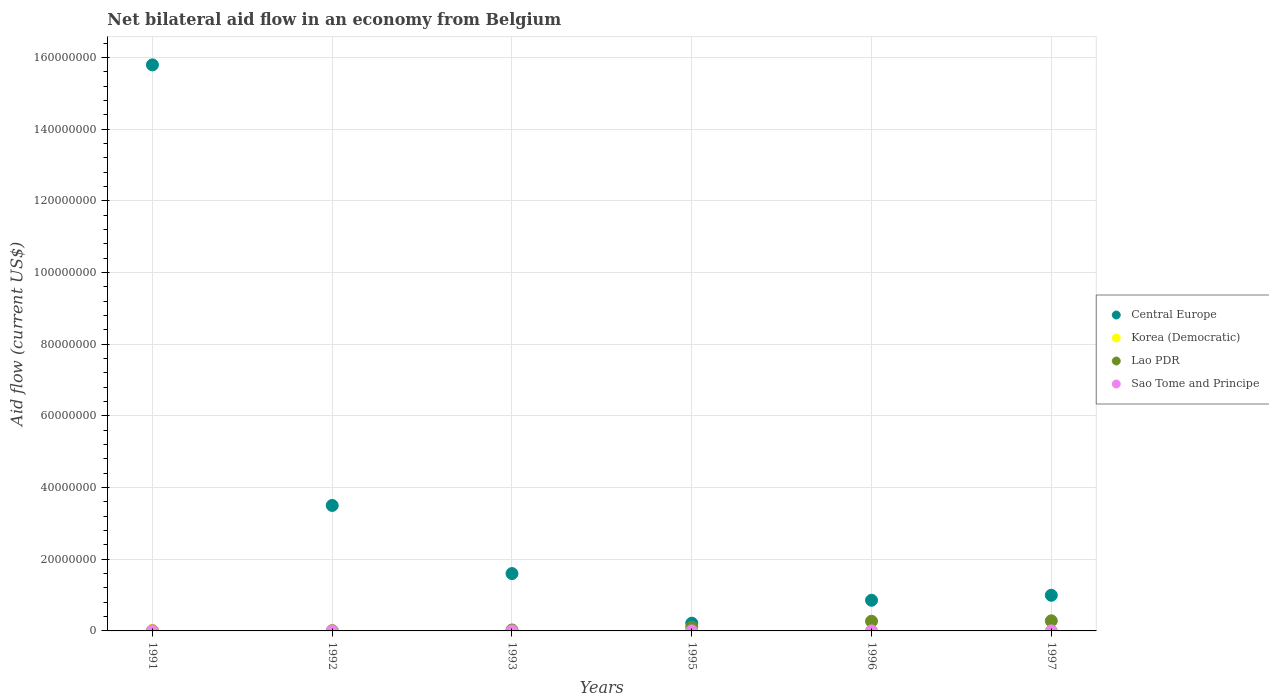How many different coloured dotlines are there?
Make the answer very short. 4. What is the net bilateral aid flow in Lao PDR in 1995?
Offer a terse response. 1.03e+06. Across all years, what is the minimum net bilateral aid flow in Korea (Democratic)?
Your response must be concise. 10000. What is the total net bilateral aid flow in Central Europe in the graph?
Provide a succinct answer. 2.30e+08. What is the difference between the net bilateral aid flow in Korea (Democratic) in 1997 and the net bilateral aid flow in Lao PDR in 1996?
Give a very brief answer. -2.69e+06. In the year 1997, what is the difference between the net bilateral aid flow in Lao PDR and net bilateral aid flow in Sao Tome and Principe?
Your answer should be very brief. 2.81e+06. In how many years, is the net bilateral aid flow in Central Europe greater than 44000000 US$?
Your response must be concise. 1. Is the difference between the net bilateral aid flow in Lao PDR in 1991 and 1992 greater than the difference between the net bilateral aid flow in Sao Tome and Principe in 1991 and 1992?
Give a very brief answer. No. What is the difference between the highest and the second highest net bilateral aid flow in Lao PDR?
Provide a short and direct response. 1.20e+05. What is the difference between the highest and the lowest net bilateral aid flow in Lao PDR?
Provide a succinct answer. 2.80e+06. Is it the case that in every year, the sum of the net bilateral aid flow in Korea (Democratic) and net bilateral aid flow in Sao Tome and Principe  is greater than the sum of net bilateral aid flow in Central Europe and net bilateral aid flow in Lao PDR?
Offer a very short reply. No. Is it the case that in every year, the sum of the net bilateral aid flow in Central Europe and net bilateral aid flow in Korea (Democratic)  is greater than the net bilateral aid flow in Lao PDR?
Your answer should be very brief. Yes. How many dotlines are there?
Provide a short and direct response. 4. Are the values on the major ticks of Y-axis written in scientific E-notation?
Offer a terse response. No. Where does the legend appear in the graph?
Your answer should be very brief. Center right. How are the legend labels stacked?
Make the answer very short. Vertical. What is the title of the graph?
Offer a very short reply. Net bilateral aid flow in an economy from Belgium. What is the label or title of the X-axis?
Ensure brevity in your answer.  Years. What is the label or title of the Y-axis?
Ensure brevity in your answer.  Aid flow (current US$). What is the Aid flow (current US$) in Central Europe in 1991?
Provide a succinct answer. 1.58e+08. What is the Aid flow (current US$) of Korea (Democratic) in 1991?
Your answer should be compact. 2.30e+05. What is the Aid flow (current US$) of Sao Tome and Principe in 1991?
Your answer should be very brief. 10000. What is the Aid flow (current US$) of Central Europe in 1992?
Make the answer very short. 3.50e+07. What is the Aid flow (current US$) in Central Europe in 1993?
Keep it short and to the point. 1.60e+07. What is the Aid flow (current US$) of Lao PDR in 1993?
Keep it short and to the point. 2.70e+05. What is the Aid flow (current US$) in Central Europe in 1995?
Keep it short and to the point. 2.16e+06. What is the Aid flow (current US$) in Korea (Democratic) in 1995?
Your response must be concise. 10000. What is the Aid flow (current US$) of Lao PDR in 1995?
Provide a succinct answer. 1.03e+06. What is the Aid flow (current US$) of Sao Tome and Principe in 1995?
Provide a short and direct response. 10000. What is the Aid flow (current US$) in Central Europe in 1996?
Offer a very short reply. 8.55e+06. What is the Aid flow (current US$) in Korea (Democratic) in 1996?
Provide a short and direct response. 10000. What is the Aid flow (current US$) in Lao PDR in 1996?
Make the answer very short. 2.70e+06. What is the Aid flow (current US$) of Sao Tome and Principe in 1996?
Offer a very short reply. 10000. What is the Aid flow (current US$) of Central Europe in 1997?
Keep it short and to the point. 9.94e+06. What is the Aid flow (current US$) of Lao PDR in 1997?
Your response must be concise. 2.82e+06. Across all years, what is the maximum Aid flow (current US$) in Central Europe?
Your answer should be very brief. 1.58e+08. Across all years, what is the maximum Aid flow (current US$) of Korea (Democratic)?
Your answer should be very brief. 2.30e+05. Across all years, what is the maximum Aid flow (current US$) of Lao PDR?
Provide a succinct answer. 2.82e+06. Across all years, what is the maximum Aid flow (current US$) of Sao Tome and Principe?
Make the answer very short. 10000. Across all years, what is the minimum Aid flow (current US$) in Central Europe?
Make the answer very short. 2.16e+06. Across all years, what is the minimum Aid flow (current US$) in Lao PDR?
Your answer should be very brief. 2.00e+04. What is the total Aid flow (current US$) of Central Europe in the graph?
Your response must be concise. 2.30e+08. What is the total Aid flow (current US$) in Korea (Democratic) in the graph?
Provide a succinct answer. 3.70e+05. What is the total Aid flow (current US$) of Lao PDR in the graph?
Keep it short and to the point. 6.91e+06. What is the total Aid flow (current US$) in Sao Tome and Principe in the graph?
Give a very brief answer. 6.00e+04. What is the difference between the Aid flow (current US$) of Central Europe in 1991 and that in 1992?
Offer a terse response. 1.23e+08. What is the difference between the Aid flow (current US$) of Lao PDR in 1991 and that in 1992?
Your answer should be compact. -5.00e+04. What is the difference between the Aid flow (current US$) in Sao Tome and Principe in 1991 and that in 1992?
Your answer should be very brief. 0. What is the difference between the Aid flow (current US$) of Central Europe in 1991 and that in 1993?
Provide a succinct answer. 1.42e+08. What is the difference between the Aid flow (current US$) of Sao Tome and Principe in 1991 and that in 1993?
Keep it short and to the point. 0. What is the difference between the Aid flow (current US$) in Central Europe in 1991 and that in 1995?
Make the answer very short. 1.56e+08. What is the difference between the Aid flow (current US$) in Korea (Democratic) in 1991 and that in 1995?
Your response must be concise. 2.20e+05. What is the difference between the Aid flow (current US$) of Lao PDR in 1991 and that in 1995?
Offer a very short reply. -1.01e+06. What is the difference between the Aid flow (current US$) in Central Europe in 1991 and that in 1996?
Offer a terse response. 1.49e+08. What is the difference between the Aid flow (current US$) of Korea (Democratic) in 1991 and that in 1996?
Offer a very short reply. 2.20e+05. What is the difference between the Aid flow (current US$) of Lao PDR in 1991 and that in 1996?
Provide a succinct answer. -2.68e+06. What is the difference between the Aid flow (current US$) of Sao Tome and Principe in 1991 and that in 1996?
Provide a succinct answer. 0. What is the difference between the Aid flow (current US$) in Central Europe in 1991 and that in 1997?
Give a very brief answer. 1.48e+08. What is the difference between the Aid flow (current US$) of Korea (Democratic) in 1991 and that in 1997?
Your answer should be compact. 2.20e+05. What is the difference between the Aid flow (current US$) in Lao PDR in 1991 and that in 1997?
Offer a very short reply. -2.80e+06. What is the difference between the Aid flow (current US$) in Sao Tome and Principe in 1991 and that in 1997?
Give a very brief answer. 0. What is the difference between the Aid flow (current US$) in Central Europe in 1992 and that in 1993?
Keep it short and to the point. 1.90e+07. What is the difference between the Aid flow (current US$) of Korea (Democratic) in 1992 and that in 1993?
Ensure brevity in your answer.  -9.00e+04. What is the difference between the Aid flow (current US$) of Lao PDR in 1992 and that in 1993?
Your answer should be compact. -2.00e+05. What is the difference between the Aid flow (current US$) in Sao Tome and Principe in 1992 and that in 1993?
Provide a succinct answer. 0. What is the difference between the Aid flow (current US$) in Central Europe in 1992 and that in 1995?
Offer a very short reply. 3.28e+07. What is the difference between the Aid flow (current US$) of Korea (Democratic) in 1992 and that in 1995?
Offer a terse response. 0. What is the difference between the Aid flow (current US$) in Lao PDR in 1992 and that in 1995?
Provide a succinct answer. -9.60e+05. What is the difference between the Aid flow (current US$) in Central Europe in 1992 and that in 1996?
Provide a succinct answer. 2.64e+07. What is the difference between the Aid flow (current US$) of Lao PDR in 1992 and that in 1996?
Keep it short and to the point. -2.63e+06. What is the difference between the Aid flow (current US$) of Sao Tome and Principe in 1992 and that in 1996?
Provide a short and direct response. 0. What is the difference between the Aid flow (current US$) in Central Europe in 1992 and that in 1997?
Keep it short and to the point. 2.51e+07. What is the difference between the Aid flow (current US$) of Lao PDR in 1992 and that in 1997?
Ensure brevity in your answer.  -2.75e+06. What is the difference between the Aid flow (current US$) of Sao Tome and Principe in 1992 and that in 1997?
Provide a short and direct response. 0. What is the difference between the Aid flow (current US$) in Central Europe in 1993 and that in 1995?
Make the answer very short. 1.38e+07. What is the difference between the Aid flow (current US$) in Korea (Democratic) in 1993 and that in 1995?
Offer a very short reply. 9.00e+04. What is the difference between the Aid flow (current US$) of Lao PDR in 1993 and that in 1995?
Your answer should be compact. -7.60e+05. What is the difference between the Aid flow (current US$) in Sao Tome and Principe in 1993 and that in 1995?
Your response must be concise. 0. What is the difference between the Aid flow (current US$) of Central Europe in 1993 and that in 1996?
Offer a very short reply. 7.45e+06. What is the difference between the Aid flow (current US$) in Korea (Democratic) in 1993 and that in 1996?
Provide a short and direct response. 9.00e+04. What is the difference between the Aid flow (current US$) of Lao PDR in 1993 and that in 1996?
Your answer should be very brief. -2.43e+06. What is the difference between the Aid flow (current US$) of Central Europe in 1993 and that in 1997?
Offer a terse response. 6.06e+06. What is the difference between the Aid flow (current US$) of Korea (Democratic) in 1993 and that in 1997?
Offer a terse response. 9.00e+04. What is the difference between the Aid flow (current US$) in Lao PDR in 1993 and that in 1997?
Offer a terse response. -2.55e+06. What is the difference between the Aid flow (current US$) in Central Europe in 1995 and that in 1996?
Provide a succinct answer. -6.39e+06. What is the difference between the Aid flow (current US$) in Korea (Democratic) in 1995 and that in 1996?
Offer a very short reply. 0. What is the difference between the Aid flow (current US$) of Lao PDR in 1995 and that in 1996?
Make the answer very short. -1.67e+06. What is the difference between the Aid flow (current US$) in Sao Tome and Principe in 1995 and that in 1996?
Your answer should be compact. 0. What is the difference between the Aid flow (current US$) in Central Europe in 1995 and that in 1997?
Offer a very short reply. -7.78e+06. What is the difference between the Aid flow (current US$) of Korea (Democratic) in 1995 and that in 1997?
Your response must be concise. 0. What is the difference between the Aid flow (current US$) in Lao PDR in 1995 and that in 1997?
Provide a short and direct response. -1.79e+06. What is the difference between the Aid flow (current US$) in Central Europe in 1996 and that in 1997?
Keep it short and to the point. -1.39e+06. What is the difference between the Aid flow (current US$) in Lao PDR in 1996 and that in 1997?
Make the answer very short. -1.20e+05. What is the difference between the Aid flow (current US$) of Sao Tome and Principe in 1996 and that in 1997?
Ensure brevity in your answer.  0. What is the difference between the Aid flow (current US$) in Central Europe in 1991 and the Aid flow (current US$) in Korea (Democratic) in 1992?
Provide a short and direct response. 1.58e+08. What is the difference between the Aid flow (current US$) of Central Europe in 1991 and the Aid flow (current US$) of Lao PDR in 1992?
Ensure brevity in your answer.  1.58e+08. What is the difference between the Aid flow (current US$) of Central Europe in 1991 and the Aid flow (current US$) of Sao Tome and Principe in 1992?
Offer a very short reply. 1.58e+08. What is the difference between the Aid flow (current US$) in Korea (Democratic) in 1991 and the Aid flow (current US$) in Lao PDR in 1992?
Keep it short and to the point. 1.60e+05. What is the difference between the Aid flow (current US$) of Korea (Democratic) in 1991 and the Aid flow (current US$) of Sao Tome and Principe in 1992?
Your response must be concise. 2.20e+05. What is the difference between the Aid flow (current US$) in Central Europe in 1991 and the Aid flow (current US$) in Korea (Democratic) in 1993?
Provide a succinct answer. 1.58e+08. What is the difference between the Aid flow (current US$) in Central Europe in 1991 and the Aid flow (current US$) in Lao PDR in 1993?
Your answer should be very brief. 1.58e+08. What is the difference between the Aid flow (current US$) in Central Europe in 1991 and the Aid flow (current US$) in Sao Tome and Principe in 1993?
Provide a short and direct response. 1.58e+08. What is the difference between the Aid flow (current US$) of Korea (Democratic) in 1991 and the Aid flow (current US$) of Sao Tome and Principe in 1993?
Make the answer very short. 2.20e+05. What is the difference between the Aid flow (current US$) of Lao PDR in 1991 and the Aid flow (current US$) of Sao Tome and Principe in 1993?
Your answer should be compact. 10000. What is the difference between the Aid flow (current US$) in Central Europe in 1991 and the Aid flow (current US$) in Korea (Democratic) in 1995?
Ensure brevity in your answer.  1.58e+08. What is the difference between the Aid flow (current US$) in Central Europe in 1991 and the Aid flow (current US$) in Lao PDR in 1995?
Provide a succinct answer. 1.57e+08. What is the difference between the Aid flow (current US$) of Central Europe in 1991 and the Aid flow (current US$) of Sao Tome and Principe in 1995?
Ensure brevity in your answer.  1.58e+08. What is the difference between the Aid flow (current US$) of Korea (Democratic) in 1991 and the Aid flow (current US$) of Lao PDR in 1995?
Your answer should be compact. -8.00e+05. What is the difference between the Aid flow (current US$) in Korea (Democratic) in 1991 and the Aid flow (current US$) in Sao Tome and Principe in 1995?
Your answer should be compact. 2.20e+05. What is the difference between the Aid flow (current US$) of Central Europe in 1991 and the Aid flow (current US$) of Korea (Democratic) in 1996?
Offer a very short reply. 1.58e+08. What is the difference between the Aid flow (current US$) of Central Europe in 1991 and the Aid flow (current US$) of Lao PDR in 1996?
Your answer should be compact. 1.55e+08. What is the difference between the Aid flow (current US$) in Central Europe in 1991 and the Aid flow (current US$) in Sao Tome and Principe in 1996?
Offer a very short reply. 1.58e+08. What is the difference between the Aid flow (current US$) in Korea (Democratic) in 1991 and the Aid flow (current US$) in Lao PDR in 1996?
Offer a very short reply. -2.47e+06. What is the difference between the Aid flow (current US$) in Korea (Democratic) in 1991 and the Aid flow (current US$) in Sao Tome and Principe in 1996?
Provide a succinct answer. 2.20e+05. What is the difference between the Aid flow (current US$) of Lao PDR in 1991 and the Aid flow (current US$) of Sao Tome and Principe in 1996?
Provide a short and direct response. 10000. What is the difference between the Aid flow (current US$) in Central Europe in 1991 and the Aid flow (current US$) in Korea (Democratic) in 1997?
Your response must be concise. 1.58e+08. What is the difference between the Aid flow (current US$) of Central Europe in 1991 and the Aid flow (current US$) of Lao PDR in 1997?
Give a very brief answer. 1.55e+08. What is the difference between the Aid flow (current US$) in Central Europe in 1991 and the Aid flow (current US$) in Sao Tome and Principe in 1997?
Provide a short and direct response. 1.58e+08. What is the difference between the Aid flow (current US$) of Korea (Democratic) in 1991 and the Aid flow (current US$) of Lao PDR in 1997?
Make the answer very short. -2.59e+06. What is the difference between the Aid flow (current US$) in Central Europe in 1992 and the Aid flow (current US$) in Korea (Democratic) in 1993?
Your answer should be compact. 3.49e+07. What is the difference between the Aid flow (current US$) in Central Europe in 1992 and the Aid flow (current US$) in Lao PDR in 1993?
Your answer should be compact. 3.47e+07. What is the difference between the Aid flow (current US$) of Central Europe in 1992 and the Aid flow (current US$) of Sao Tome and Principe in 1993?
Your response must be concise. 3.50e+07. What is the difference between the Aid flow (current US$) in Korea (Democratic) in 1992 and the Aid flow (current US$) in Sao Tome and Principe in 1993?
Your answer should be compact. 0. What is the difference between the Aid flow (current US$) of Central Europe in 1992 and the Aid flow (current US$) of Korea (Democratic) in 1995?
Make the answer very short. 3.50e+07. What is the difference between the Aid flow (current US$) in Central Europe in 1992 and the Aid flow (current US$) in Lao PDR in 1995?
Your answer should be very brief. 3.40e+07. What is the difference between the Aid flow (current US$) in Central Europe in 1992 and the Aid flow (current US$) in Sao Tome and Principe in 1995?
Make the answer very short. 3.50e+07. What is the difference between the Aid flow (current US$) of Korea (Democratic) in 1992 and the Aid flow (current US$) of Lao PDR in 1995?
Make the answer very short. -1.02e+06. What is the difference between the Aid flow (current US$) in Korea (Democratic) in 1992 and the Aid flow (current US$) in Sao Tome and Principe in 1995?
Offer a very short reply. 0. What is the difference between the Aid flow (current US$) of Central Europe in 1992 and the Aid flow (current US$) of Korea (Democratic) in 1996?
Make the answer very short. 3.50e+07. What is the difference between the Aid flow (current US$) of Central Europe in 1992 and the Aid flow (current US$) of Lao PDR in 1996?
Ensure brevity in your answer.  3.23e+07. What is the difference between the Aid flow (current US$) of Central Europe in 1992 and the Aid flow (current US$) of Sao Tome and Principe in 1996?
Ensure brevity in your answer.  3.50e+07. What is the difference between the Aid flow (current US$) of Korea (Democratic) in 1992 and the Aid flow (current US$) of Lao PDR in 1996?
Give a very brief answer. -2.69e+06. What is the difference between the Aid flow (current US$) of Korea (Democratic) in 1992 and the Aid flow (current US$) of Sao Tome and Principe in 1996?
Give a very brief answer. 0. What is the difference between the Aid flow (current US$) in Central Europe in 1992 and the Aid flow (current US$) in Korea (Democratic) in 1997?
Your response must be concise. 3.50e+07. What is the difference between the Aid flow (current US$) of Central Europe in 1992 and the Aid flow (current US$) of Lao PDR in 1997?
Keep it short and to the point. 3.22e+07. What is the difference between the Aid flow (current US$) in Central Europe in 1992 and the Aid flow (current US$) in Sao Tome and Principe in 1997?
Make the answer very short. 3.50e+07. What is the difference between the Aid flow (current US$) of Korea (Democratic) in 1992 and the Aid flow (current US$) of Lao PDR in 1997?
Provide a short and direct response. -2.81e+06. What is the difference between the Aid flow (current US$) in Korea (Democratic) in 1992 and the Aid flow (current US$) in Sao Tome and Principe in 1997?
Keep it short and to the point. 0. What is the difference between the Aid flow (current US$) of Central Europe in 1993 and the Aid flow (current US$) of Korea (Democratic) in 1995?
Make the answer very short. 1.60e+07. What is the difference between the Aid flow (current US$) in Central Europe in 1993 and the Aid flow (current US$) in Lao PDR in 1995?
Make the answer very short. 1.50e+07. What is the difference between the Aid flow (current US$) of Central Europe in 1993 and the Aid flow (current US$) of Sao Tome and Principe in 1995?
Your answer should be compact. 1.60e+07. What is the difference between the Aid flow (current US$) in Korea (Democratic) in 1993 and the Aid flow (current US$) in Lao PDR in 1995?
Keep it short and to the point. -9.30e+05. What is the difference between the Aid flow (current US$) of Central Europe in 1993 and the Aid flow (current US$) of Korea (Democratic) in 1996?
Give a very brief answer. 1.60e+07. What is the difference between the Aid flow (current US$) of Central Europe in 1993 and the Aid flow (current US$) of Lao PDR in 1996?
Give a very brief answer. 1.33e+07. What is the difference between the Aid flow (current US$) of Central Europe in 1993 and the Aid flow (current US$) of Sao Tome and Principe in 1996?
Make the answer very short. 1.60e+07. What is the difference between the Aid flow (current US$) of Korea (Democratic) in 1993 and the Aid flow (current US$) of Lao PDR in 1996?
Make the answer very short. -2.60e+06. What is the difference between the Aid flow (current US$) in Central Europe in 1993 and the Aid flow (current US$) in Korea (Democratic) in 1997?
Your answer should be very brief. 1.60e+07. What is the difference between the Aid flow (current US$) in Central Europe in 1993 and the Aid flow (current US$) in Lao PDR in 1997?
Make the answer very short. 1.32e+07. What is the difference between the Aid flow (current US$) in Central Europe in 1993 and the Aid flow (current US$) in Sao Tome and Principe in 1997?
Your answer should be compact. 1.60e+07. What is the difference between the Aid flow (current US$) in Korea (Democratic) in 1993 and the Aid flow (current US$) in Lao PDR in 1997?
Make the answer very short. -2.72e+06. What is the difference between the Aid flow (current US$) of Korea (Democratic) in 1993 and the Aid flow (current US$) of Sao Tome and Principe in 1997?
Provide a succinct answer. 9.00e+04. What is the difference between the Aid flow (current US$) in Lao PDR in 1993 and the Aid flow (current US$) in Sao Tome and Principe in 1997?
Make the answer very short. 2.60e+05. What is the difference between the Aid flow (current US$) of Central Europe in 1995 and the Aid flow (current US$) of Korea (Democratic) in 1996?
Provide a short and direct response. 2.15e+06. What is the difference between the Aid flow (current US$) of Central Europe in 1995 and the Aid flow (current US$) of Lao PDR in 1996?
Offer a terse response. -5.40e+05. What is the difference between the Aid flow (current US$) in Central Europe in 1995 and the Aid flow (current US$) in Sao Tome and Principe in 1996?
Make the answer very short. 2.15e+06. What is the difference between the Aid flow (current US$) in Korea (Democratic) in 1995 and the Aid flow (current US$) in Lao PDR in 1996?
Keep it short and to the point. -2.69e+06. What is the difference between the Aid flow (current US$) of Korea (Democratic) in 1995 and the Aid flow (current US$) of Sao Tome and Principe in 1996?
Give a very brief answer. 0. What is the difference between the Aid flow (current US$) in Lao PDR in 1995 and the Aid flow (current US$) in Sao Tome and Principe in 1996?
Make the answer very short. 1.02e+06. What is the difference between the Aid flow (current US$) of Central Europe in 1995 and the Aid flow (current US$) of Korea (Democratic) in 1997?
Provide a short and direct response. 2.15e+06. What is the difference between the Aid flow (current US$) in Central Europe in 1995 and the Aid flow (current US$) in Lao PDR in 1997?
Your answer should be very brief. -6.60e+05. What is the difference between the Aid flow (current US$) of Central Europe in 1995 and the Aid flow (current US$) of Sao Tome and Principe in 1997?
Give a very brief answer. 2.15e+06. What is the difference between the Aid flow (current US$) of Korea (Democratic) in 1995 and the Aid flow (current US$) of Lao PDR in 1997?
Provide a short and direct response. -2.81e+06. What is the difference between the Aid flow (current US$) of Lao PDR in 1995 and the Aid flow (current US$) of Sao Tome and Principe in 1997?
Your answer should be very brief. 1.02e+06. What is the difference between the Aid flow (current US$) of Central Europe in 1996 and the Aid flow (current US$) of Korea (Democratic) in 1997?
Provide a succinct answer. 8.54e+06. What is the difference between the Aid flow (current US$) of Central Europe in 1996 and the Aid flow (current US$) of Lao PDR in 1997?
Make the answer very short. 5.73e+06. What is the difference between the Aid flow (current US$) of Central Europe in 1996 and the Aid flow (current US$) of Sao Tome and Principe in 1997?
Your answer should be compact. 8.54e+06. What is the difference between the Aid flow (current US$) in Korea (Democratic) in 1996 and the Aid flow (current US$) in Lao PDR in 1997?
Keep it short and to the point. -2.81e+06. What is the difference between the Aid flow (current US$) in Lao PDR in 1996 and the Aid flow (current US$) in Sao Tome and Principe in 1997?
Ensure brevity in your answer.  2.69e+06. What is the average Aid flow (current US$) in Central Europe per year?
Make the answer very short. 3.83e+07. What is the average Aid flow (current US$) in Korea (Democratic) per year?
Offer a very short reply. 6.17e+04. What is the average Aid flow (current US$) in Lao PDR per year?
Offer a very short reply. 1.15e+06. In the year 1991, what is the difference between the Aid flow (current US$) of Central Europe and Aid flow (current US$) of Korea (Democratic)?
Offer a very short reply. 1.58e+08. In the year 1991, what is the difference between the Aid flow (current US$) in Central Europe and Aid flow (current US$) in Lao PDR?
Provide a succinct answer. 1.58e+08. In the year 1991, what is the difference between the Aid flow (current US$) in Central Europe and Aid flow (current US$) in Sao Tome and Principe?
Your answer should be very brief. 1.58e+08. In the year 1991, what is the difference between the Aid flow (current US$) in Korea (Democratic) and Aid flow (current US$) in Lao PDR?
Offer a terse response. 2.10e+05. In the year 1991, what is the difference between the Aid flow (current US$) in Korea (Democratic) and Aid flow (current US$) in Sao Tome and Principe?
Your answer should be very brief. 2.20e+05. In the year 1991, what is the difference between the Aid flow (current US$) in Lao PDR and Aid flow (current US$) in Sao Tome and Principe?
Provide a succinct answer. 10000. In the year 1992, what is the difference between the Aid flow (current US$) in Central Europe and Aid flow (current US$) in Korea (Democratic)?
Offer a very short reply. 3.50e+07. In the year 1992, what is the difference between the Aid flow (current US$) in Central Europe and Aid flow (current US$) in Lao PDR?
Offer a terse response. 3.49e+07. In the year 1992, what is the difference between the Aid flow (current US$) in Central Europe and Aid flow (current US$) in Sao Tome and Principe?
Your answer should be compact. 3.50e+07. In the year 1992, what is the difference between the Aid flow (current US$) in Lao PDR and Aid flow (current US$) in Sao Tome and Principe?
Offer a terse response. 6.00e+04. In the year 1993, what is the difference between the Aid flow (current US$) of Central Europe and Aid flow (current US$) of Korea (Democratic)?
Give a very brief answer. 1.59e+07. In the year 1993, what is the difference between the Aid flow (current US$) in Central Europe and Aid flow (current US$) in Lao PDR?
Provide a succinct answer. 1.57e+07. In the year 1993, what is the difference between the Aid flow (current US$) in Central Europe and Aid flow (current US$) in Sao Tome and Principe?
Your answer should be compact. 1.60e+07. In the year 1993, what is the difference between the Aid flow (current US$) in Korea (Democratic) and Aid flow (current US$) in Sao Tome and Principe?
Your answer should be very brief. 9.00e+04. In the year 1993, what is the difference between the Aid flow (current US$) of Lao PDR and Aid flow (current US$) of Sao Tome and Principe?
Offer a very short reply. 2.60e+05. In the year 1995, what is the difference between the Aid flow (current US$) in Central Europe and Aid flow (current US$) in Korea (Democratic)?
Provide a succinct answer. 2.15e+06. In the year 1995, what is the difference between the Aid flow (current US$) of Central Europe and Aid flow (current US$) of Lao PDR?
Keep it short and to the point. 1.13e+06. In the year 1995, what is the difference between the Aid flow (current US$) of Central Europe and Aid flow (current US$) of Sao Tome and Principe?
Your answer should be compact. 2.15e+06. In the year 1995, what is the difference between the Aid flow (current US$) in Korea (Democratic) and Aid flow (current US$) in Lao PDR?
Keep it short and to the point. -1.02e+06. In the year 1995, what is the difference between the Aid flow (current US$) of Lao PDR and Aid flow (current US$) of Sao Tome and Principe?
Provide a short and direct response. 1.02e+06. In the year 1996, what is the difference between the Aid flow (current US$) of Central Europe and Aid flow (current US$) of Korea (Democratic)?
Your answer should be compact. 8.54e+06. In the year 1996, what is the difference between the Aid flow (current US$) in Central Europe and Aid flow (current US$) in Lao PDR?
Your answer should be compact. 5.85e+06. In the year 1996, what is the difference between the Aid flow (current US$) in Central Europe and Aid flow (current US$) in Sao Tome and Principe?
Provide a short and direct response. 8.54e+06. In the year 1996, what is the difference between the Aid flow (current US$) in Korea (Democratic) and Aid flow (current US$) in Lao PDR?
Keep it short and to the point. -2.69e+06. In the year 1996, what is the difference between the Aid flow (current US$) in Lao PDR and Aid flow (current US$) in Sao Tome and Principe?
Ensure brevity in your answer.  2.69e+06. In the year 1997, what is the difference between the Aid flow (current US$) in Central Europe and Aid flow (current US$) in Korea (Democratic)?
Ensure brevity in your answer.  9.93e+06. In the year 1997, what is the difference between the Aid flow (current US$) in Central Europe and Aid flow (current US$) in Lao PDR?
Your answer should be very brief. 7.12e+06. In the year 1997, what is the difference between the Aid flow (current US$) of Central Europe and Aid flow (current US$) of Sao Tome and Principe?
Give a very brief answer. 9.93e+06. In the year 1997, what is the difference between the Aid flow (current US$) of Korea (Democratic) and Aid flow (current US$) of Lao PDR?
Make the answer very short. -2.81e+06. In the year 1997, what is the difference between the Aid flow (current US$) in Lao PDR and Aid flow (current US$) in Sao Tome and Principe?
Give a very brief answer. 2.81e+06. What is the ratio of the Aid flow (current US$) of Central Europe in 1991 to that in 1992?
Provide a succinct answer. 4.51. What is the ratio of the Aid flow (current US$) of Korea (Democratic) in 1991 to that in 1992?
Provide a succinct answer. 23. What is the ratio of the Aid flow (current US$) of Lao PDR in 1991 to that in 1992?
Offer a very short reply. 0.29. What is the ratio of the Aid flow (current US$) in Sao Tome and Principe in 1991 to that in 1992?
Provide a succinct answer. 1. What is the ratio of the Aid flow (current US$) in Central Europe in 1991 to that in 1993?
Offer a very short reply. 9.87. What is the ratio of the Aid flow (current US$) in Korea (Democratic) in 1991 to that in 1993?
Offer a terse response. 2.3. What is the ratio of the Aid flow (current US$) of Lao PDR in 1991 to that in 1993?
Keep it short and to the point. 0.07. What is the ratio of the Aid flow (current US$) in Central Europe in 1991 to that in 1995?
Provide a succinct answer. 73.1. What is the ratio of the Aid flow (current US$) of Korea (Democratic) in 1991 to that in 1995?
Ensure brevity in your answer.  23. What is the ratio of the Aid flow (current US$) in Lao PDR in 1991 to that in 1995?
Keep it short and to the point. 0.02. What is the ratio of the Aid flow (current US$) of Central Europe in 1991 to that in 1996?
Offer a very short reply. 18.47. What is the ratio of the Aid flow (current US$) of Lao PDR in 1991 to that in 1996?
Provide a short and direct response. 0.01. What is the ratio of the Aid flow (current US$) of Sao Tome and Principe in 1991 to that in 1996?
Your answer should be very brief. 1. What is the ratio of the Aid flow (current US$) of Central Europe in 1991 to that in 1997?
Provide a short and direct response. 15.89. What is the ratio of the Aid flow (current US$) of Lao PDR in 1991 to that in 1997?
Keep it short and to the point. 0.01. What is the ratio of the Aid flow (current US$) in Central Europe in 1992 to that in 1993?
Ensure brevity in your answer.  2.19. What is the ratio of the Aid flow (current US$) of Lao PDR in 1992 to that in 1993?
Your answer should be compact. 0.26. What is the ratio of the Aid flow (current US$) in Sao Tome and Principe in 1992 to that in 1993?
Your response must be concise. 1. What is the ratio of the Aid flow (current US$) in Central Europe in 1992 to that in 1995?
Give a very brief answer. 16.2. What is the ratio of the Aid flow (current US$) of Lao PDR in 1992 to that in 1995?
Make the answer very short. 0.07. What is the ratio of the Aid flow (current US$) in Central Europe in 1992 to that in 1996?
Your response must be concise. 4.09. What is the ratio of the Aid flow (current US$) in Lao PDR in 1992 to that in 1996?
Provide a short and direct response. 0.03. What is the ratio of the Aid flow (current US$) in Central Europe in 1992 to that in 1997?
Your answer should be very brief. 3.52. What is the ratio of the Aid flow (current US$) of Lao PDR in 1992 to that in 1997?
Keep it short and to the point. 0.02. What is the ratio of the Aid flow (current US$) of Central Europe in 1993 to that in 1995?
Make the answer very short. 7.41. What is the ratio of the Aid flow (current US$) of Korea (Democratic) in 1993 to that in 1995?
Make the answer very short. 10. What is the ratio of the Aid flow (current US$) in Lao PDR in 1993 to that in 1995?
Provide a short and direct response. 0.26. What is the ratio of the Aid flow (current US$) in Central Europe in 1993 to that in 1996?
Make the answer very short. 1.87. What is the ratio of the Aid flow (current US$) in Lao PDR in 1993 to that in 1996?
Make the answer very short. 0.1. What is the ratio of the Aid flow (current US$) of Sao Tome and Principe in 1993 to that in 1996?
Offer a very short reply. 1. What is the ratio of the Aid flow (current US$) of Central Europe in 1993 to that in 1997?
Your response must be concise. 1.61. What is the ratio of the Aid flow (current US$) of Lao PDR in 1993 to that in 1997?
Your response must be concise. 0.1. What is the ratio of the Aid flow (current US$) of Sao Tome and Principe in 1993 to that in 1997?
Ensure brevity in your answer.  1. What is the ratio of the Aid flow (current US$) of Central Europe in 1995 to that in 1996?
Offer a very short reply. 0.25. What is the ratio of the Aid flow (current US$) of Korea (Democratic) in 1995 to that in 1996?
Your answer should be compact. 1. What is the ratio of the Aid flow (current US$) of Lao PDR in 1995 to that in 1996?
Ensure brevity in your answer.  0.38. What is the ratio of the Aid flow (current US$) of Sao Tome and Principe in 1995 to that in 1996?
Give a very brief answer. 1. What is the ratio of the Aid flow (current US$) of Central Europe in 1995 to that in 1997?
Ensure brevity in your answer.  0.22. What is the ratio of the Aid flow (current US$) of Korea (Democratic) in 1995 to that in 1997?
Offer a very short reply. 1. What is the ratio of the Aid flow (current US$) of Lao PDR in 1995 to that in 1997?
Your answer should be very brief. 0.37. What is the ratio of the Aid flow (current US$) of Central Europe in 1996 to that in 1997?
Provide a succinct answer. 0.86. What is the ratio of the Aid flow (current US$) of Lao PDR in 1996 to that in 1997?
Ensure brevity in your answer.  0.96. What is the ratio of the Aid flow (current US$) of Sao Tome and Principe in 1996 to that in 1997?
Offer a very short reply. 1. What is the difference between the highest and the second highest Aid flow (current US$) of Central Europe?
Your answer should be very brief. 1.23e+08. What is the difference between the highest and the second highest Aid flow (current US$) of Korea (Democratic)?
Give a very brief answer. 1.30e+05. What is the difference between the highest and the second highest Aid flow (current US$) of Lao PDR?
Make the answer very short. 1.20e+05. What is the difference between the highest and the second highest Aid flow (current US$) in Sao Tome and Principe?
Keep it short and to the point. 0. What is the difference between the highest and the lowest Aid flow (current US$) in Central Europe?
Offer a very short reply. 1.56e+08. What is the difference between the highest and the lowest Aid flow (current US$) in Korea (Democratic)?
Your answer should be very brief. 2.20e+05. What is the difference between the highest and the lowest Aid flow (current US$) in Lao PDR?
Ensure brevity in your answer.  2.80e+06. 